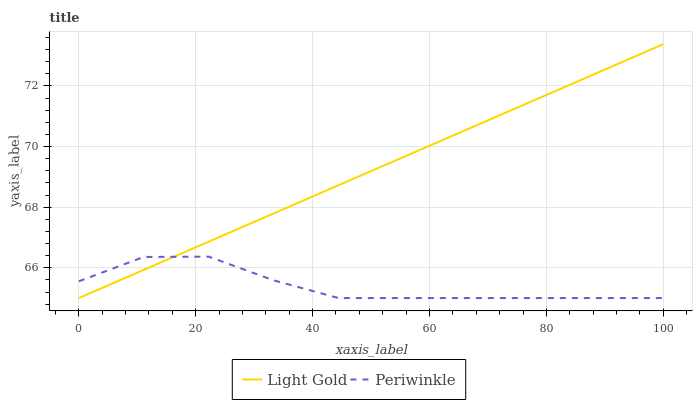Does Periwinkle have the minimum area under the curve?
Answer yes or no. Yes. Does Light Gold have the maximum area under the curve?
Answer yes or no. Yes. Does Light Gold have the minimum area under the curve?
Answer yes or no. No. Is Light Gold the smoothest?
Answer yes or no. Yes. Is Periwinkle the roughest?
Answer yes or no. Yes. Is Light Gold the roughest?
Answer yes or no. No. Does Periwinkle have the lowest value?
Answer yes or no. Yes. Does Light Gold have the highest value?
Answer yes or no. Yes. Does Periwinkle intersect Light Gold?
Answer yes or no. Yes. Is Periwinkle less than Light Gold?
Answer yes or no. No. Is Periwinkle greater than Light Gold?
Answer yes or no. No. 